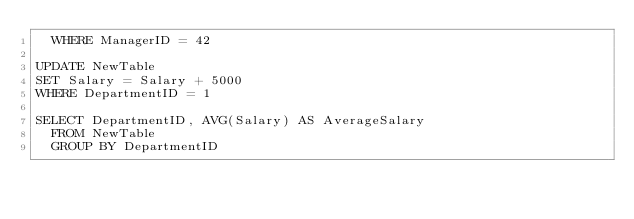Convert code to text. <code><loc_0><loc_0><loc_500><loc_500><_SQL_>	WHERE ManagerID = 42

UPDATE NewTable
SET Salary = Salary + 5000
WHERE DepartmentID = 1

SELECT DepartmentID, AVG(Salary) AS AverageSalary
	FROM NewTable
	GROUP BY DepartmentID</code> 